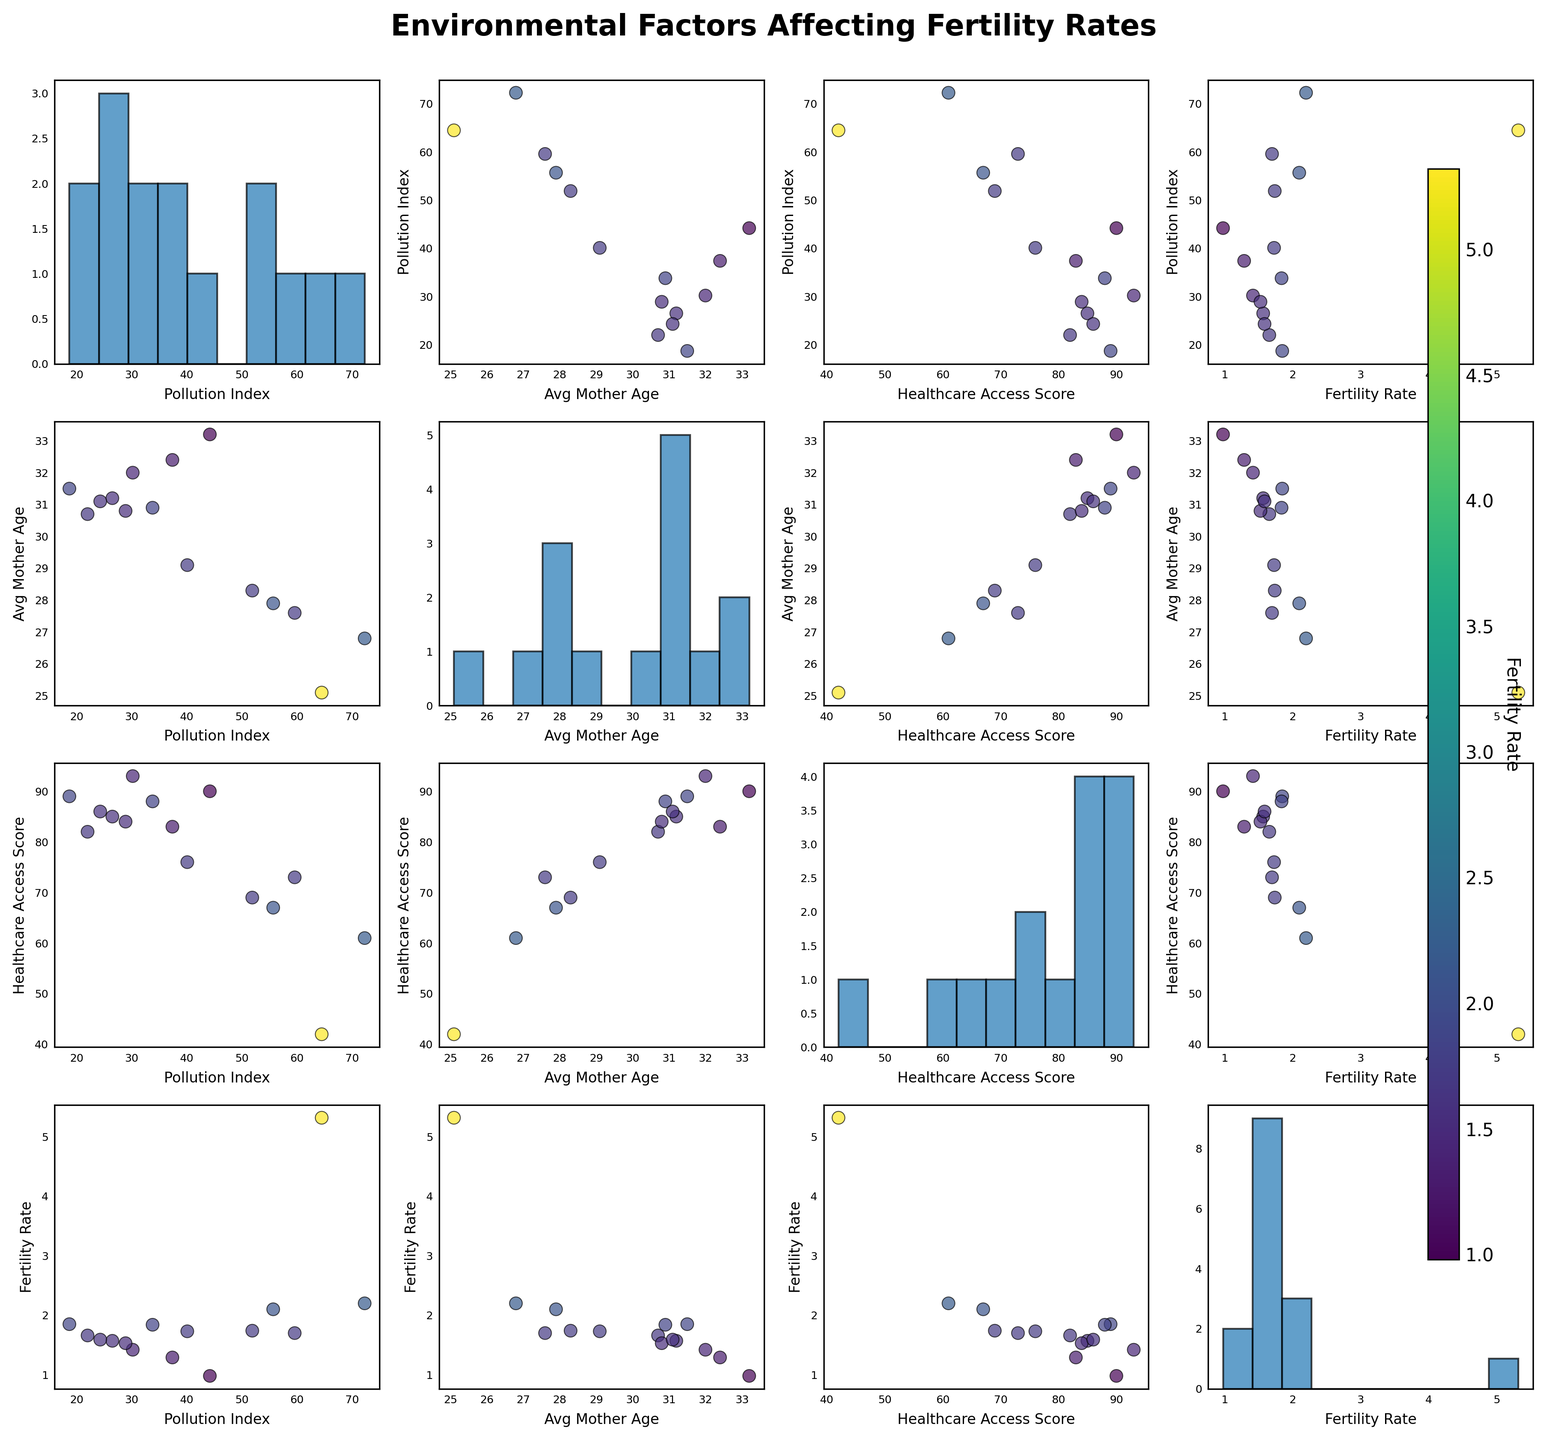What variables are included in the scatterplot matrix? The scatterplot matrix includes the variables 'Pollution Index,' 'Average Mother Age,' 'Healthcare Access Score,' and 'Fertility Rate,' as visible from the labels on the axes.
Answer: 'Pollution Index,' 'Average Mother Age,' 'Healthcare Access Score,' 'Fertility Rate' Which variable has the highest value of fertility rate among the countries? Nigeria has the highest fertility rate. This is visible from the scatter plots where the data point representing Nigeria (labeled with the highest fertility rate) stands out significantly.
Answer: Nigeria How does the average mother age correlate with the fertility rate based on the scatterplot matrix? The scatter plot shows a general trend where countries with a higher average mother age tend to have lower fertility rates. This is visible by observing the scatterplots where both the average mother age and fertility rate are plotted on their respective axes, showing a downward trend.
Answer: Negative correlation Do countries with higher healthcare access scores tend to have lower or higher fertility rates? Countries with higher healthcare access scores tend to have lower fertility rates. This is inferred from the scatterplots that plot 'Healthcare Access Score' against 'Fertility Rate,' showing a general downward trend.
Answer: Lower What is the relationship between pollution index and fertility rate? The scatterplots show a slight positive trend where countries with higher pollution indices tend to have higher fertility rates. This can be seen by comparing the 'Pollution Index' with 'Fertility Rate' data points.
Answer: Positive correlation Which country appears to have an outlier fertility rate, and what is that rate? Nigeria appears to be an outlier with a fertility rate of 5.32, significantly higher than the other countries. This is observable from the scatterplots where Nigeria is distinctly separated at the top in terms of fertility rate.
Answer: Nigeria, 5.32 Between 'Average Mother Age' and 'Pollution Index,' which variable seems to have a more consistent distribution across the countries? 'Average Mother Age' appears more consistent, as observed from the histograms along the diagonal. The histogram for 'Average Mother Age' shows a more uniform distribution compared to 'Pollution Index,' which has a wider range and more varied distribution.
Answer: Average Mother Age Which countries have a healthcare access score higher than 85, and what are their fertility rates? The countries with healthcare access scores higher than 85 are Germany, Sweden, France, and South Korea. Their fertility rates are 1.57, 1.85, 1.84, and 0.98, respectively. This can be confirmed from the axis labels and the color coding in scatter plots.
Answer: Germany (1.57), Sweden (1.85), France (1.84), South Korea (0.98) What do the color variations in the scatter plots indicate? The color variations, ranging from darker to lighter shades, indicate the fertility rate of each country. Darker colors represent lower fertility rates, while lighter colors represent higher fertility rates, as shown by the color bar on the side of the figure.
Answer: Fertility Rate 